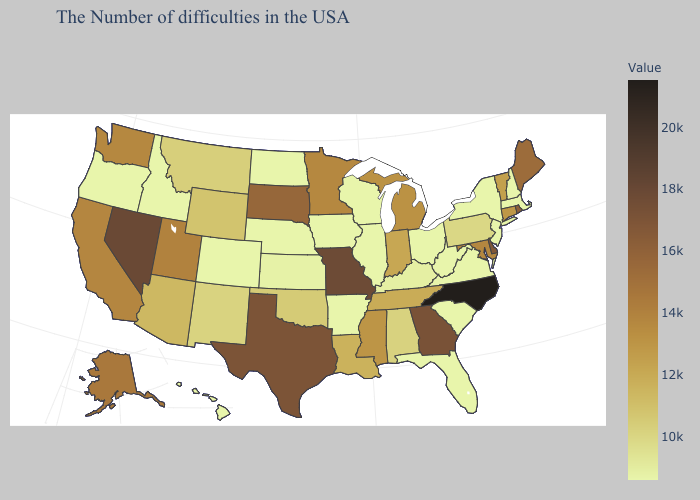Among the states that border Maryland , does Delaware have the lowest value?
Quick response, please. No. Does Iowa have a lower value than Connecticut?
Be succinct. Yes. Among the states that border South Dakota , which have the highest value?
Write a very short answer. Minnesota. Which states hav the highest value in the MidWest?
Answer briefly. Missouri. Does Rhode Island have the lowest value in the USA?
Be succinct. No. Among the states that border Georgia , which have the highest value?
Write a very short answer. North Carolina. Which states have the lowest value in the West?
Write a very short answer. Colorado, Idaho, Oregon, Hawaii. 